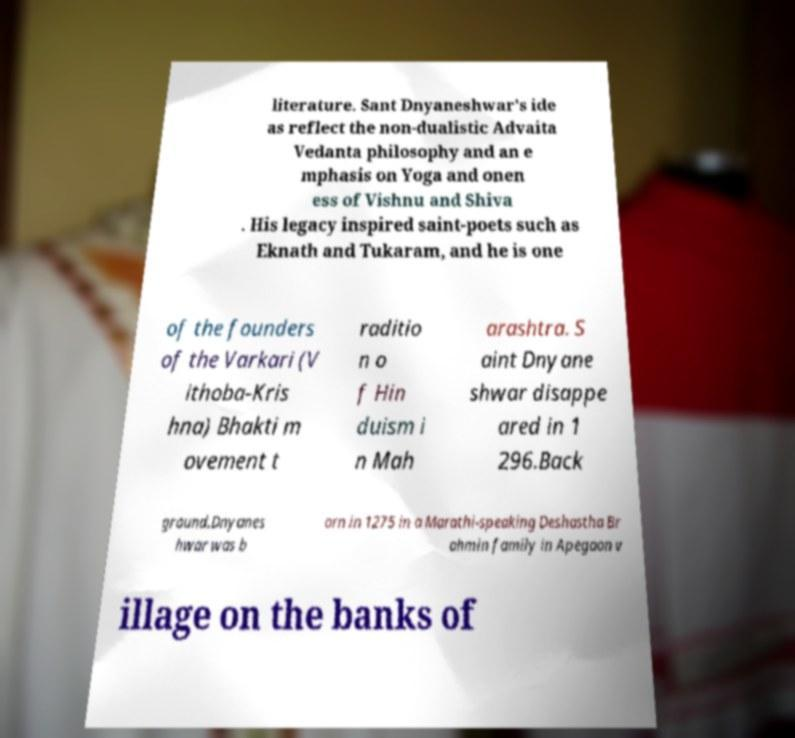What messages or text are displayed in this image? I need them in a readable, typed format. literature. Sant Dnyaneshwar's ide as reflect the non-dualistic Advaita Vedanta philosophy and an e mphasis on Yoga and onen ess of Vishnu and Shiva . His legacy inspired saint-poets such as Eknath and Tukaram, and he is one of the founders of the Varkari (V ithoba-Kris hna) Bhakti m ovement t raditio n o f Hin duism i n Mah arashtra. S aint Dnyane shwar disappe ared in 1 296.Back ground.Dnyanes hwar was b orn in 1275 in a Marathi-speaking Deshastha Br ahmin family in Apegaon v illage on the banks of 